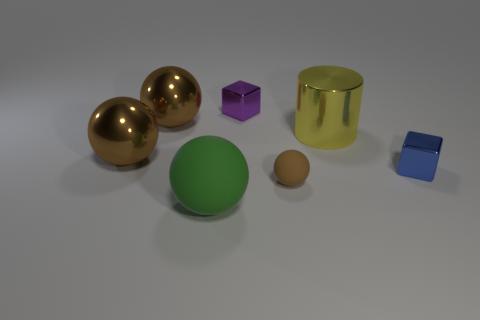The other rubber object that is the same shape as the green object is what color?
Ensure brevity in your answer.  Brown. What number of things are tiny cubes behind the blue metal cube or metallic things in front of the small purple metal cube?
Your response must be concise. 5. The big green rubber thing is what shape?
Your answer should be very brief. Sphere. How many brown things have the same material as the big green thing?
Provide a short and direct response. 1. What is the color of the small matte object?
Your response must be concise. Brown. What color is the rubber ball that is the same size as the yellow metallic thing?
Make the answer very short. Green. Are there any other balls that have the same color as the small ball?
Keep it short and to the point. Yes. Is the shape of the small shiny object that is on the left side of the tiny ball the same as the tiny shiny thing that is right of the brown rubber sphere?
Provide a succinct answer. Yes. How many other objects are the same size as the metallic cylinder?
Make the answer very short. 3. Does the small rubber thing have the same color as the big thing behind the metal cylinder?
Provide a succinct answer. Yes. 